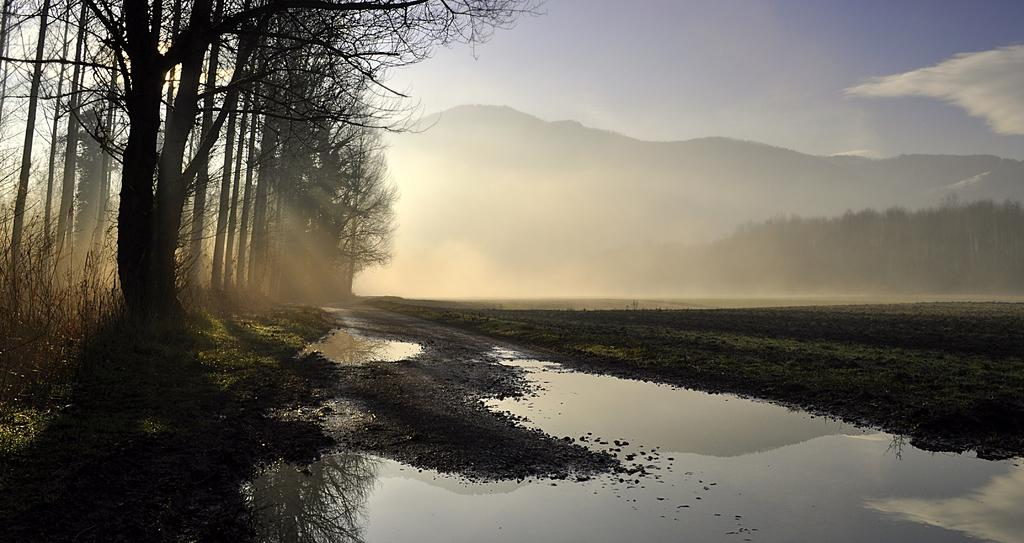What type of natural landform can be seen in the image? There are mountains in the image. What other natural elements are present in the image? There are trees, water, and grass visible in the image. What is visible at the top of the image? The sky is visible at the top of the image, and there are clouds in the sky. What is visible at the bottom of the image? There is water visible at the bottom of the image. What is the ground like in the image? The ground is visible in the image, and there is grass present. Can you describe the lighting in the image? Sunlight is present in the image. What type of linen is draped over the top of the mountain in the image? There is no linen present in the image; it is a natural landscape featuring mountains, trees, water, and grass. 